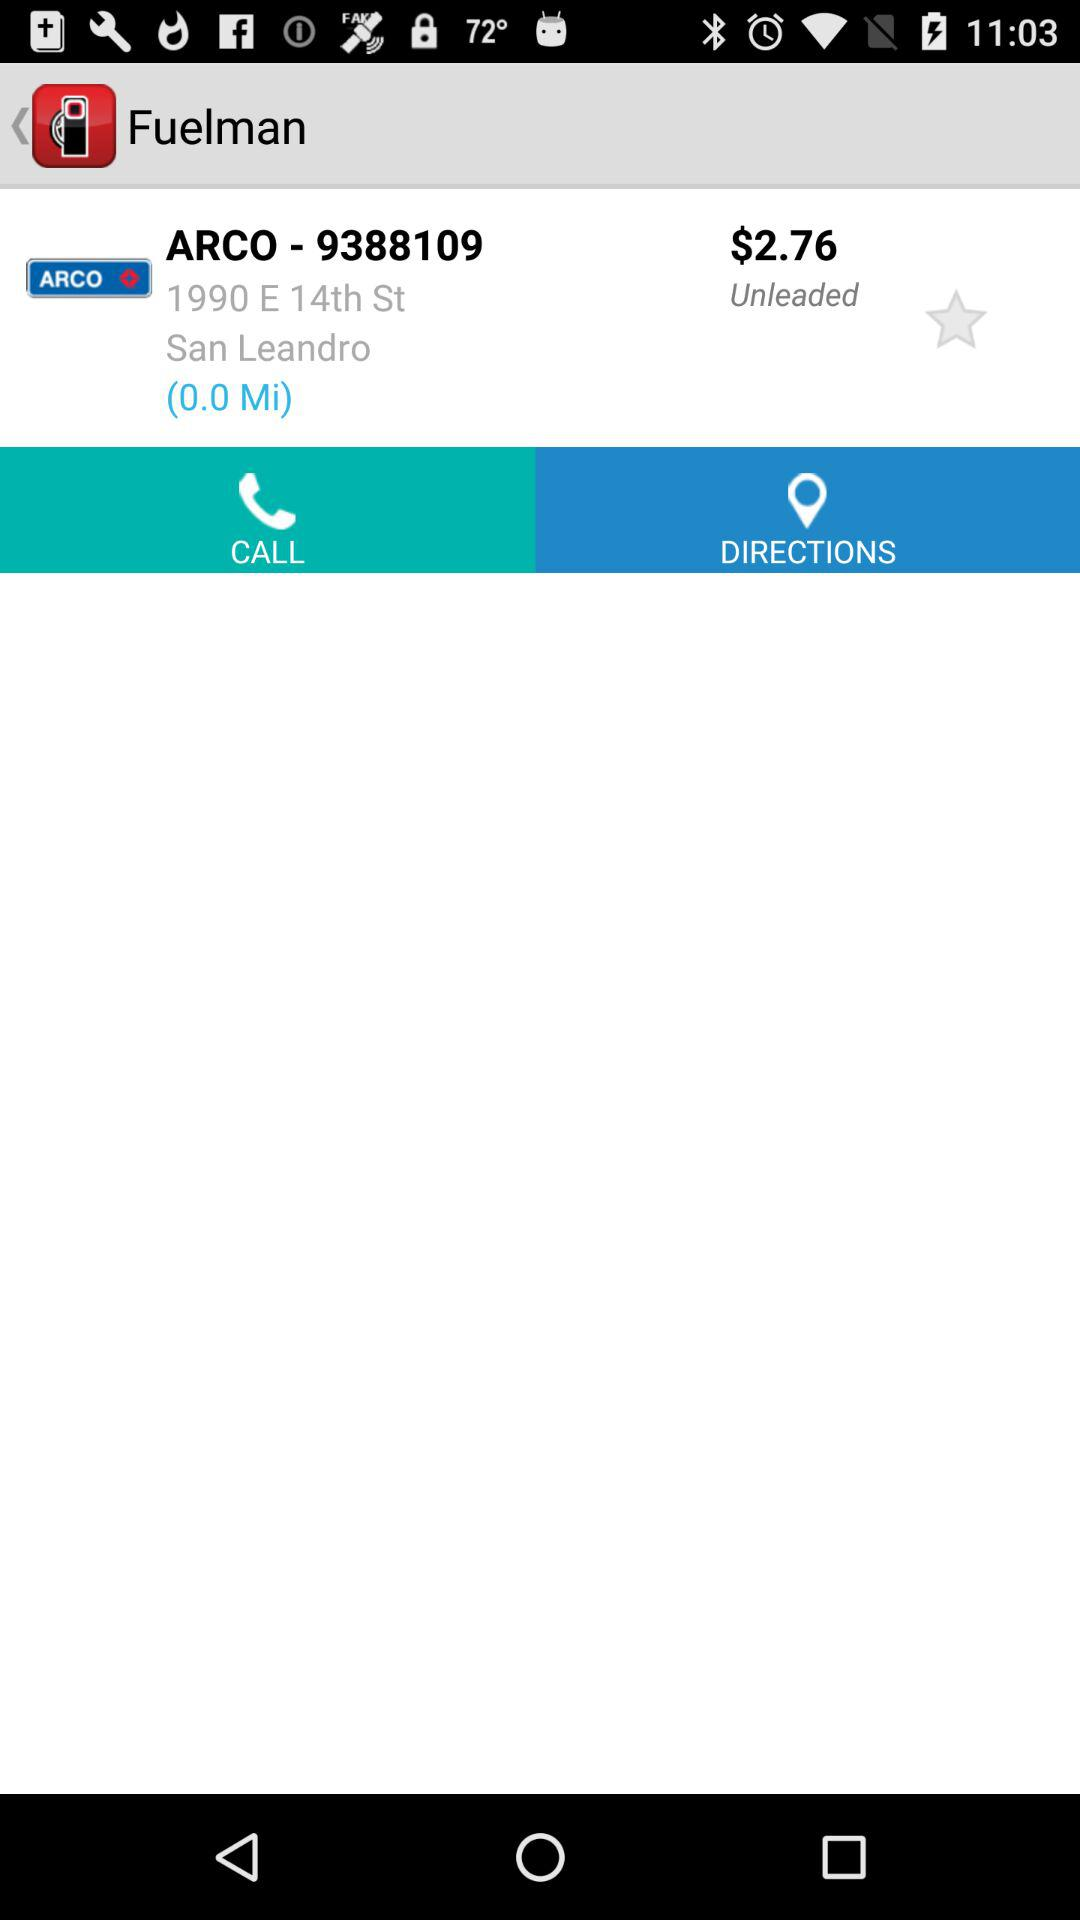How far is "ARCO"? "ARCO" is 0.0 miles away. 